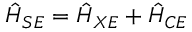Convert formula to latex. <formula><loc_0><loc_0><loc_500><loc_500>\hat { H } _ { S E } = \hat { H } _ { X E } + \hat { H } _ { C E }</formula> 